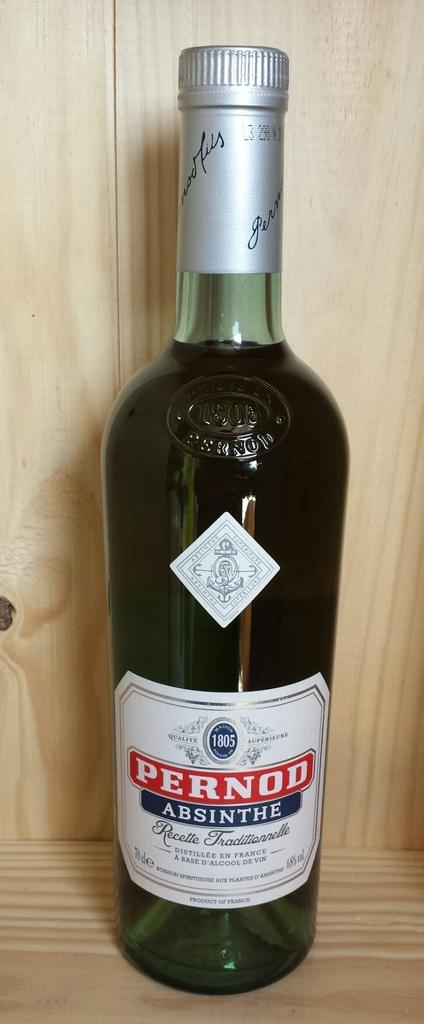<image>
Write a terse but informative summary of the picture. A bottle has the brand name Pernod on it. 